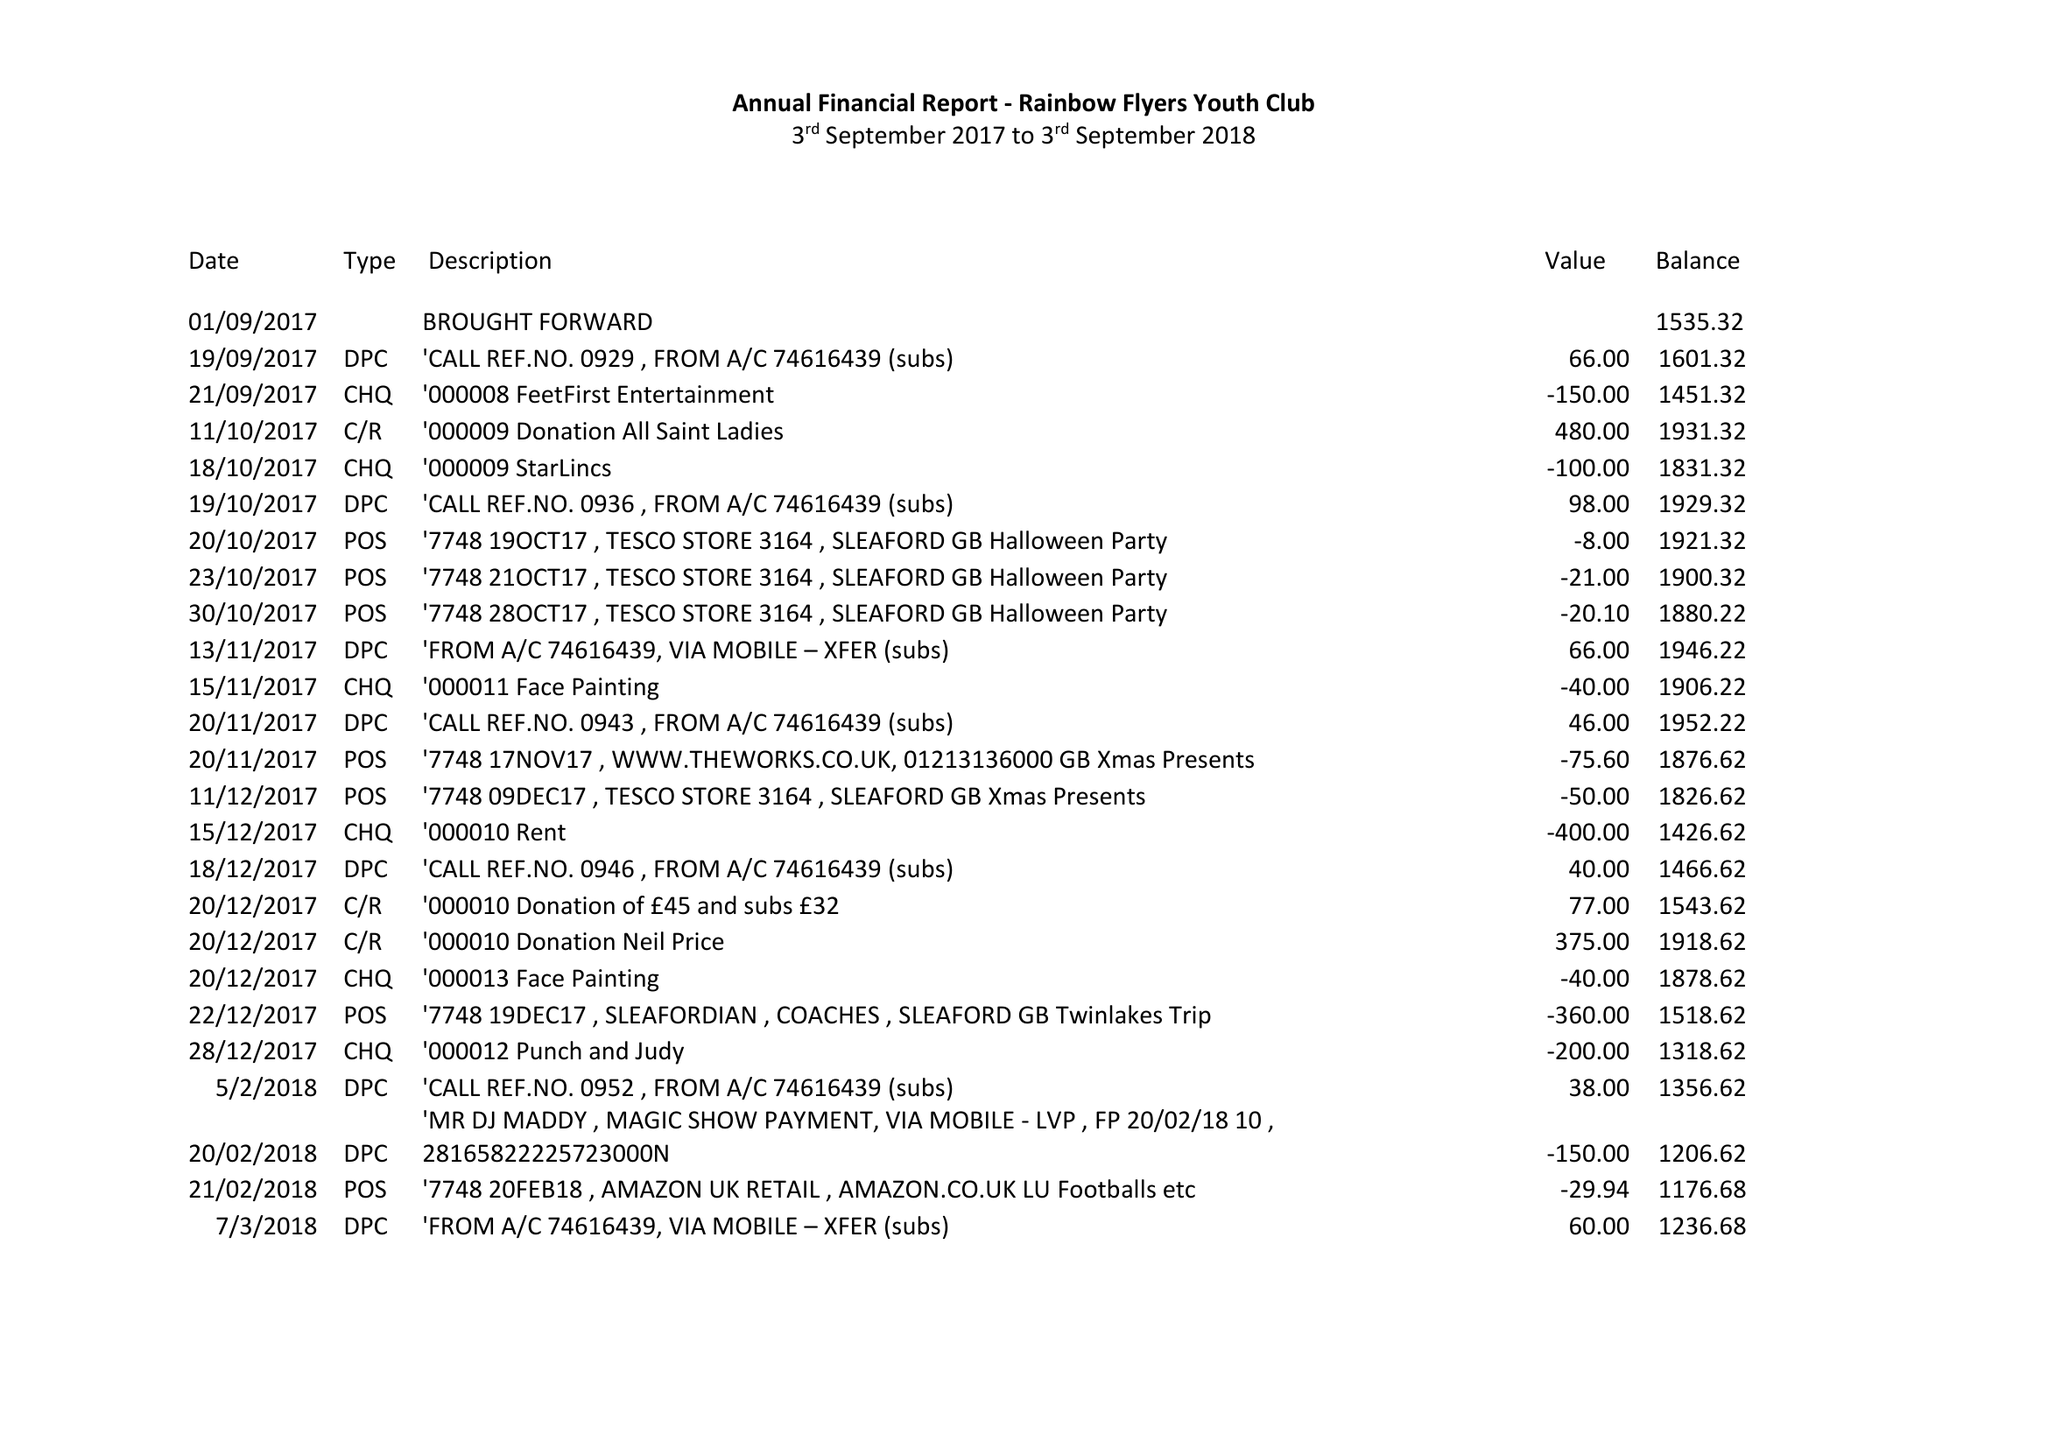What is the value for the address__postcode?
Answer the question using a single word or phrase. NG34 9DW 